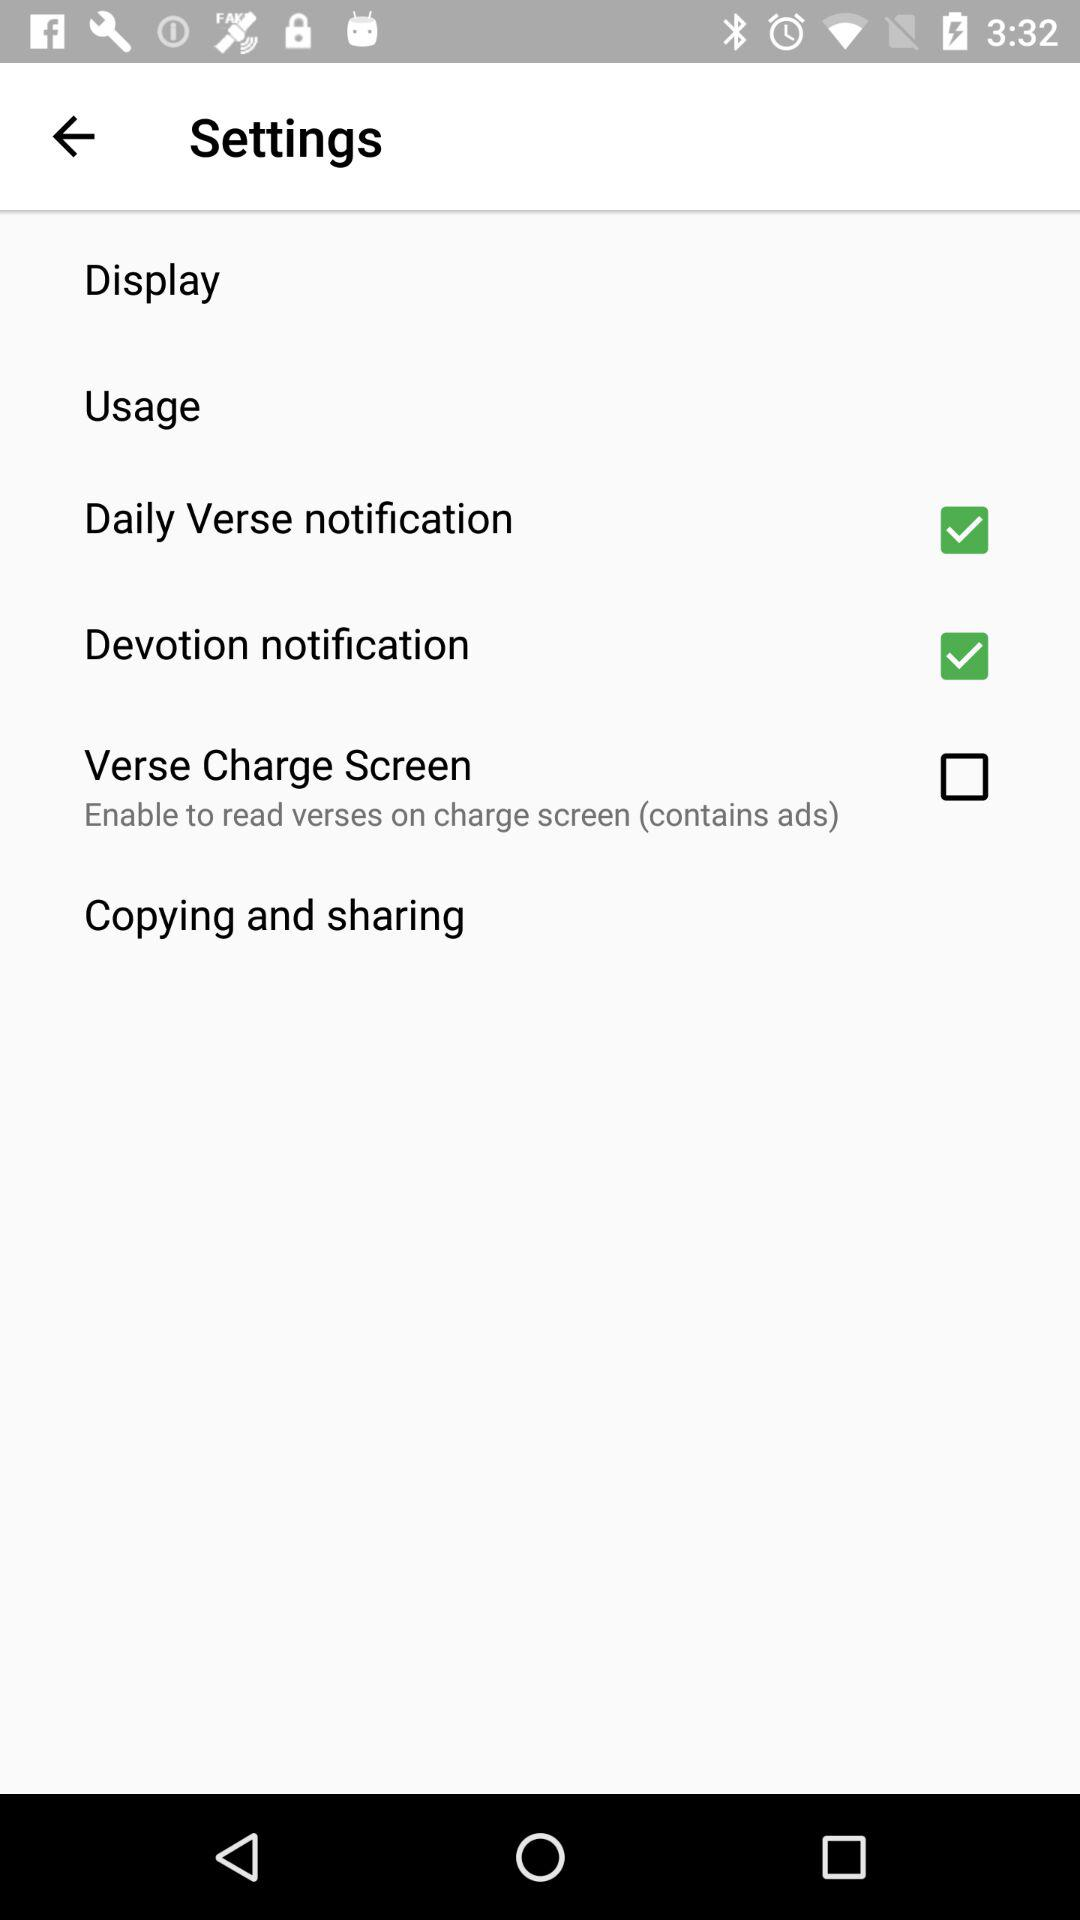Is "Copying and sharing" selected or not selected?
When the provided information is insufficient, respond with <no answer>. <no answer> 